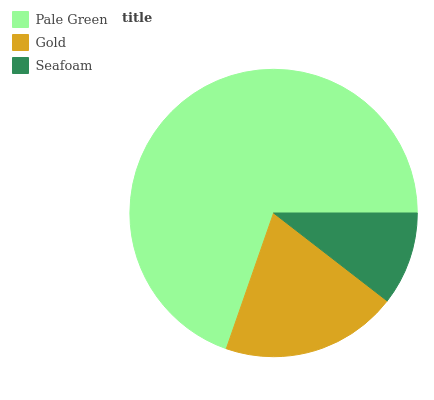Is Seafoam the minimum?
Answer yes or no. Yes. Is Pale Green the maximum?
Answer yes or no. Yes. Is Gold the minimum?
Answer yes or no. No. Is Gold the maximum?
Answer yes or no. No. Is Pale Green greater than Gold?
Answer yes or no. Yes. Is Gold less than Pale Green?
Answer yes or no. Yes. Is Gold greater than Pale Green?
Answer yes or no. No. Is Pale Green less than Gold?
Answer yes or no. No. Is Gold the high median?
Answer yes or no. Yes. Is Gold the low median?
Answer yes or no. Yes. Is Pale Green the high median?
Answer yes or no. No. Is Seafoam the low median?
Answer yes or no. No. 